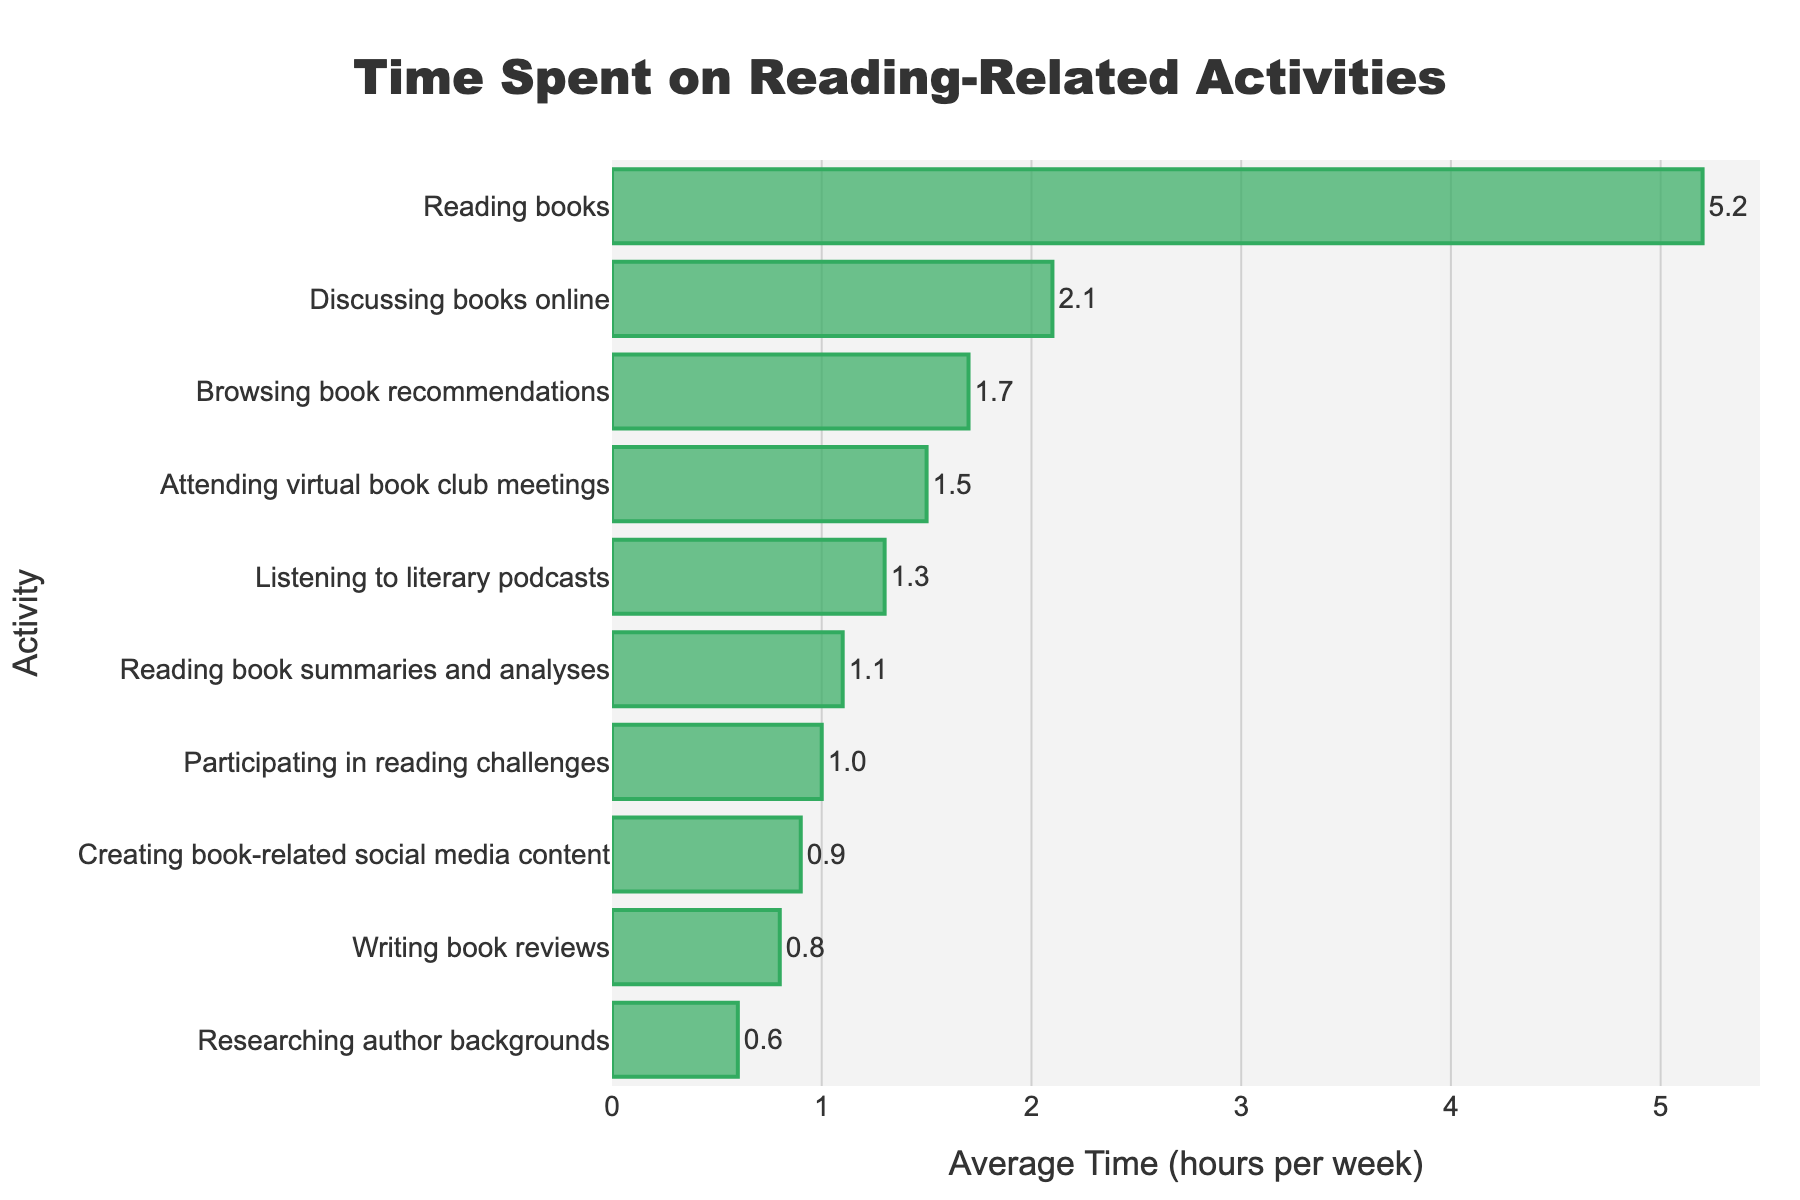Which activity do book club members spend the most time on? The longest bar in the chart is for "Reading books," indicating that it has the highest average time spent, which is 5.2 hours per week.
Answer: Reading books What is the combined average time spent on writing book reviews and creating book-related social media content? The average time spent on writing book reviews is 0.8 hours per week and on creating book-related social media content is 0.9 hours per week. Adding these together gives 0.8 + 0.9 = 1.7 hours per week.
Answer: 1.7 Which activities have average times greater than 2 hours per week? By looking at the bars longer than 2 hours, "Reading books" (5.2 hours) and "Discussing books online" (2.1 hours) have average times greater than 2 hours per week.
Answer: Reading books, Discussing books online How much more time do members spend reading books compared to attending virtual book club meetings? Members spend 5.2 hours per week reading books and 1.5 hours per week attending virtual book club meetings. The difference is 5.2 - 1.5 = 3.7 hours per week.
Answer: 3.7 Which activity has the shortest average time spent, and what is that time? The shortest bar in the chart is for "Researching author backgrounds," indicating that it has the lowest average time spent, which is 0.6 hours per week.
Answer: Researching author backgrounds, 0.6 Is the time spent on listening to literary podcasts more or less than the time spent on browsing book recommendations? The average time spent on listening to literary podcasts is 1.3 hours per week, while on browsing book recommendations it is 1.7 hours per week. Since 1.3 < 1.7, members spend less time on literary podcasts compared to browsing book recommendations.
Answer: Less What is the total average time spent on all activities combined? The sum of the average times for all activities is 5.2 + 2.1 + 1.5 + 0.8 + 0.6 + 1.3 + 1.0 + 1.7 + 0.9 + 1.1 = 16.2 hours per week.
Answer: 16.2 Which two activities have the closest average times spent, and what are those times? The closest average times are for "Participating in reading challenges" (1.0 hours) and "Creating book-related social media content" (0.9 hours), with a difference of 0.1 hours.
Answer: Participating in reading challenges and Creating book-related social media content, 1.0 and 0.9 How many activities have an average time between 1 and 2 hours per week? The activities with average times between 1 and 2 hours per week are "Listening to literary podcasts" (1.3), "Participating in reading challenges" (1.0), "Browsing book recommendations" (1.7), and "Reading book summaries and analyses" (1.1). Thus, there are 4 activities.
Answer: 4 